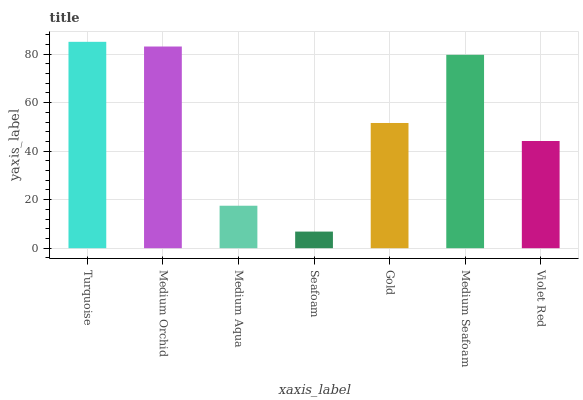Is Seafoam the minimum?
Answer yes or no. Yes. Is Turquoise the maximum?
Answer yes or no. Yes. Is Medium Orchid the minimum?
Answer yes or no. No. Is Medium Orchid the maximum?
Answer yes or no. No. Is Turquoise greater than Medium Orchid?
Answer yes or no. Yes. Is Medium Orchid less than Turquoise?
Answer yes or no. Yes. Is Medium Orchid greater than Turquoise?
Answer yes or no. No. Is Turquoise less than Medium Orchid?
Answer yes or no. No. Is Gold the high median?
Answer yes or no. Yes. Is Gold the low median?
Answer yes or no. Yes. Is Seafoam the high median?
Answer yes or no. No. Is Violet Red the low median?
Answer yes or no. No. 